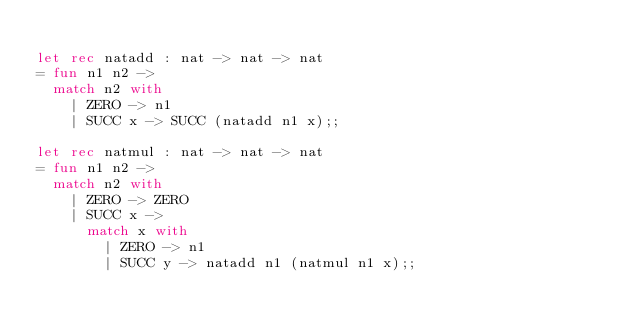Convert code to text. <code><loc_0><loc_0><loc_500><loc_500><_OCaml_>
let rec natadd : nat -> nat -> nat
= fun n1 n2 -> 
  match n2 with
    | ZERO -> n1
    | SUCC x -> SUCC (natadd n1 x);; 

let rec natmul : nat -> nat -> nat
= fun n1 n2 -> 
  match n2 with
    | ZERO -> ZERO
    | SUCC x ->
      match x with
        | ZERO -> n1
        | SUCC y -> natadd n1 (natmul n1 x);;
        

</code> 